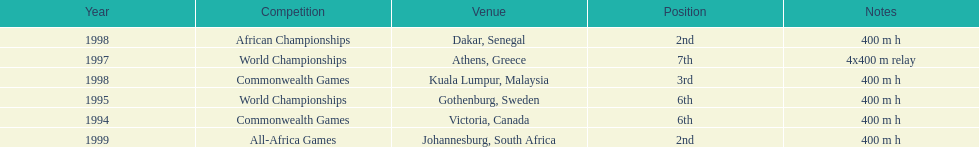Can you give me this table as a dict? {'header': ['Year', 'Competition', 'Venue', 'Position', 'Notes'], 'rows': [['1998', 'African Championships', 'Dakar, Senegal', '2nd', '400 m h'], ['1997', 'World Championships', 'Athens, Greece', '7th', '4x400 m relay'], ['1998', 'Commonwealth Games', 'Kuala Lumpur, Malaysia', '3rd', '400 m h'], ['1995', 'World Championships', 'Gothenburg, Sweden', '6th', '400 m h'], ['1994', 'Commonwealth Games', 'Victoria, Canada', '6th', '400 m h'], ['1999', 'All-Africa Games', 'Johannesburg, South Africa', '2nd', '400 m h']]} What is the number of titles ken harden has one 6. 